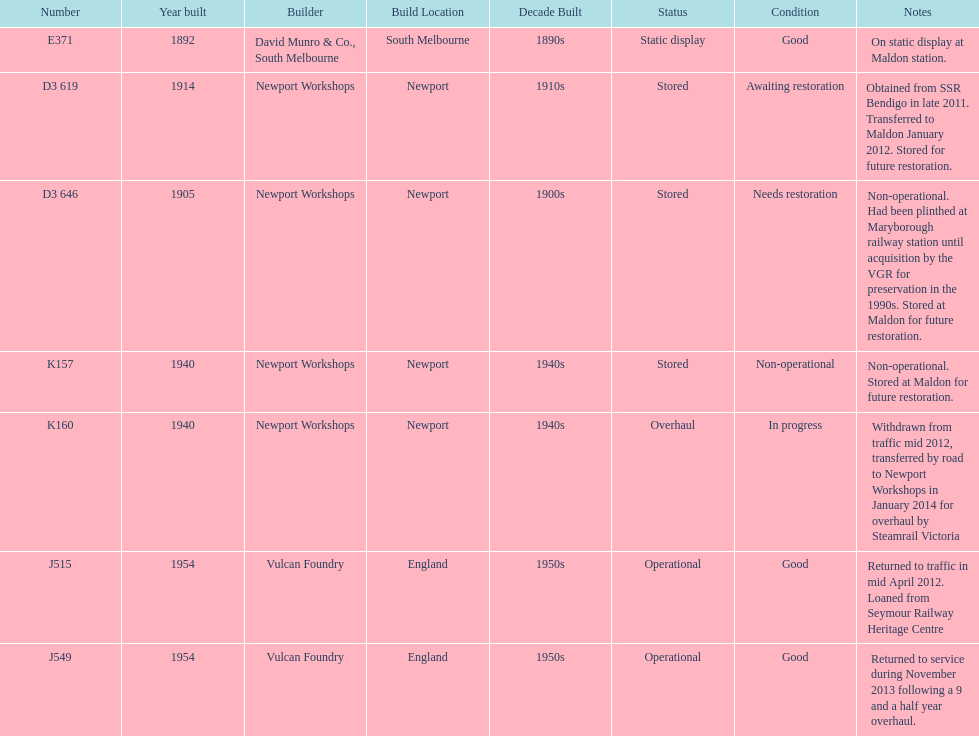How many of the locomotives were built before 1940? 3. 